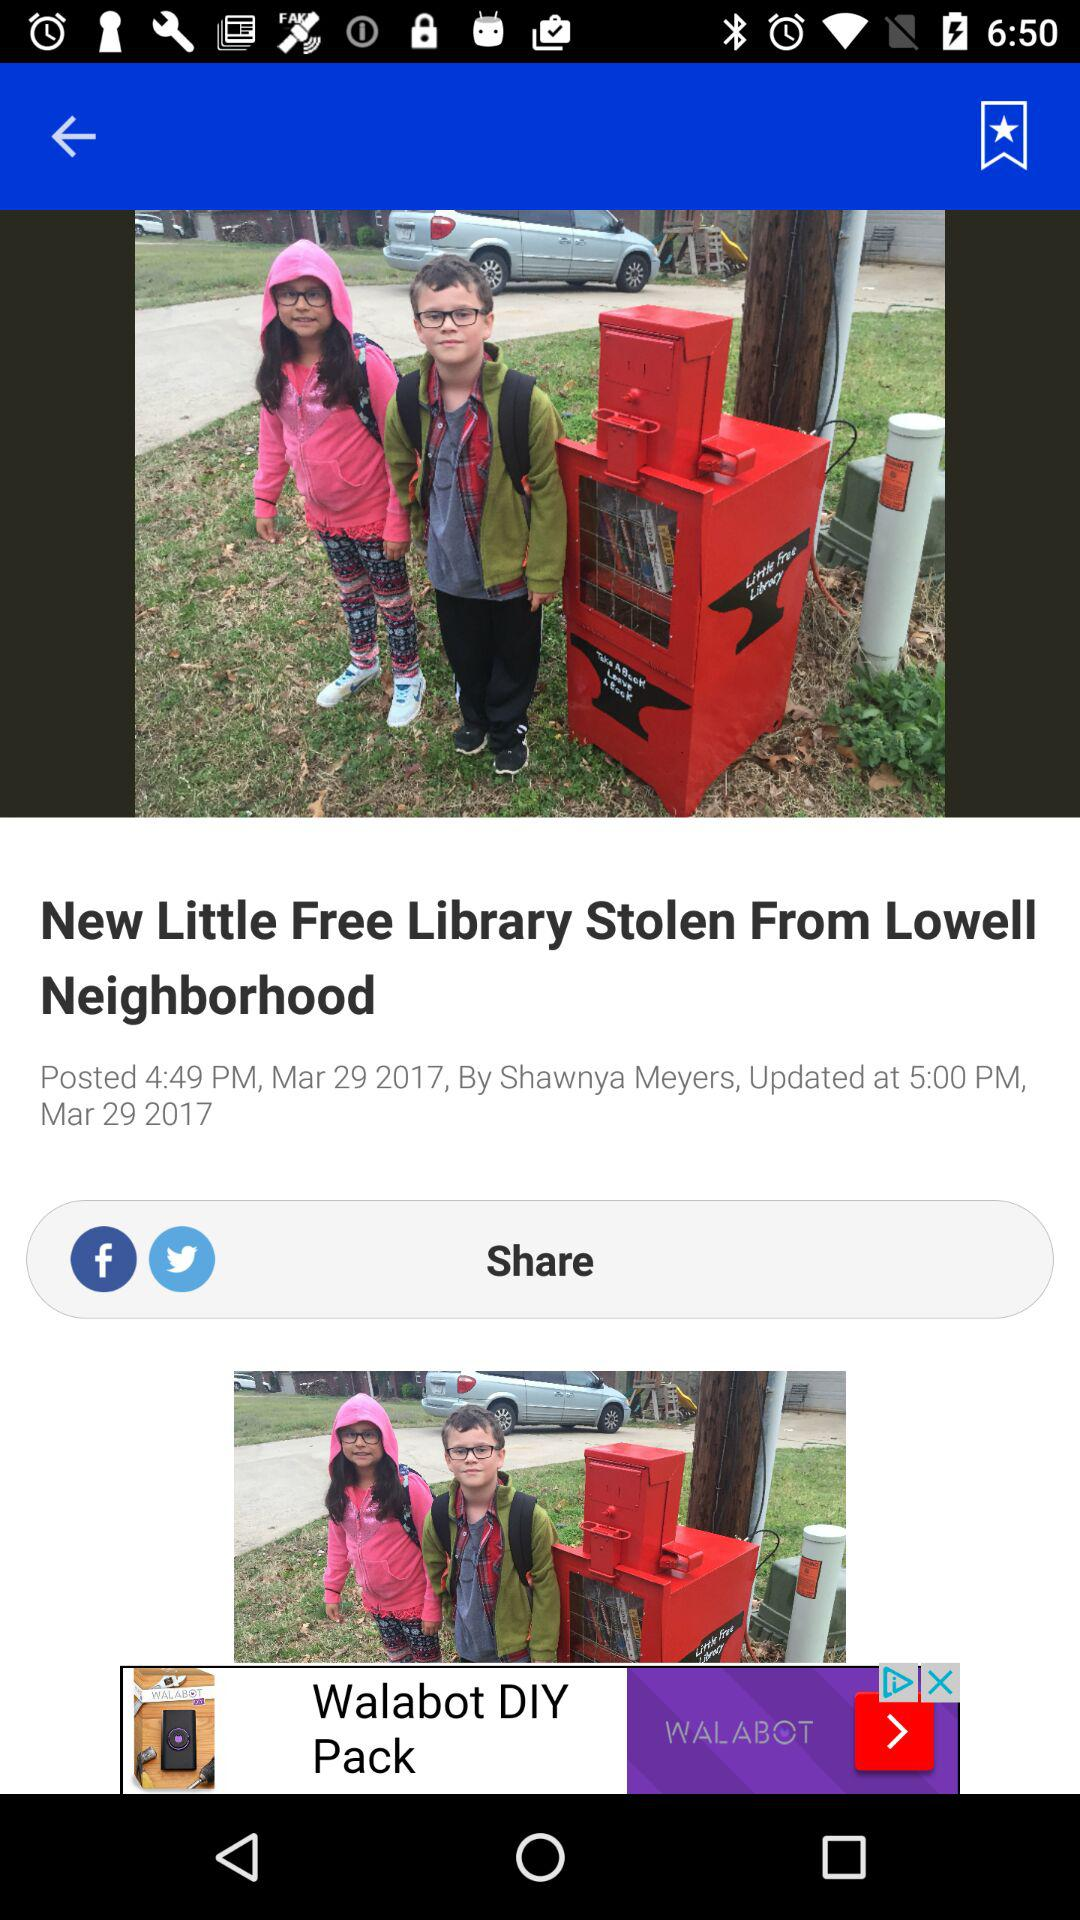By whom was the article written? The article was written by Shawnya Meyers. 